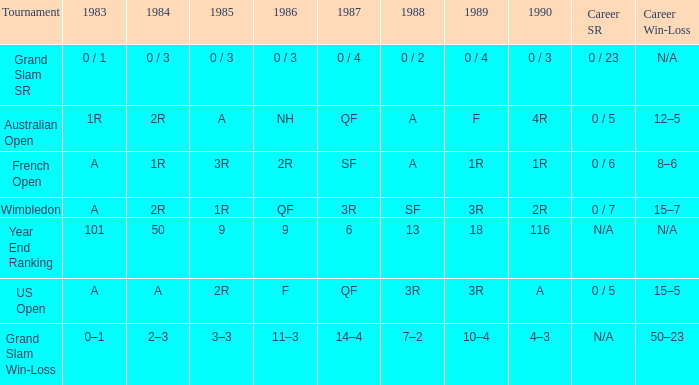What is the result in 1985 when the career win-loss is n/a, and 0 / 23 as the career SR? 0 / 3. 